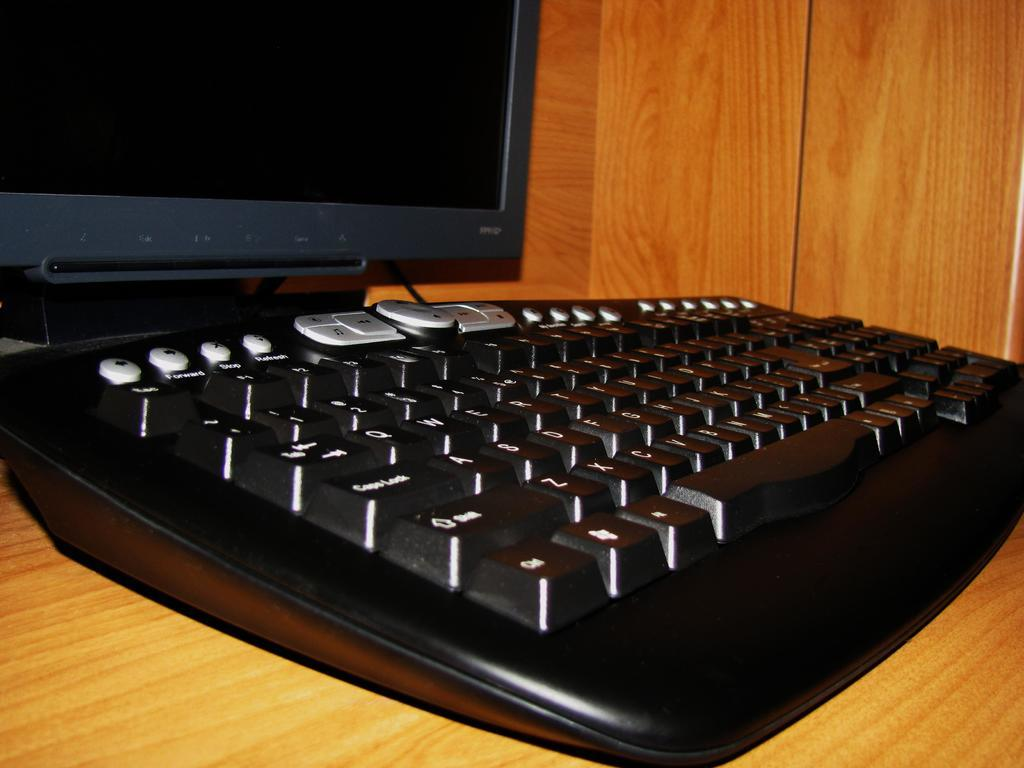What type of device is visible in the image? There is a keyboard in the image. What is the keyboard placed on in the image? There is a desktop in the image, and both the keyboard and the desktop are on a table. What type of activity is the group engaging in together in the image? There is no group present in the image, and no activity is being performed by a group. 